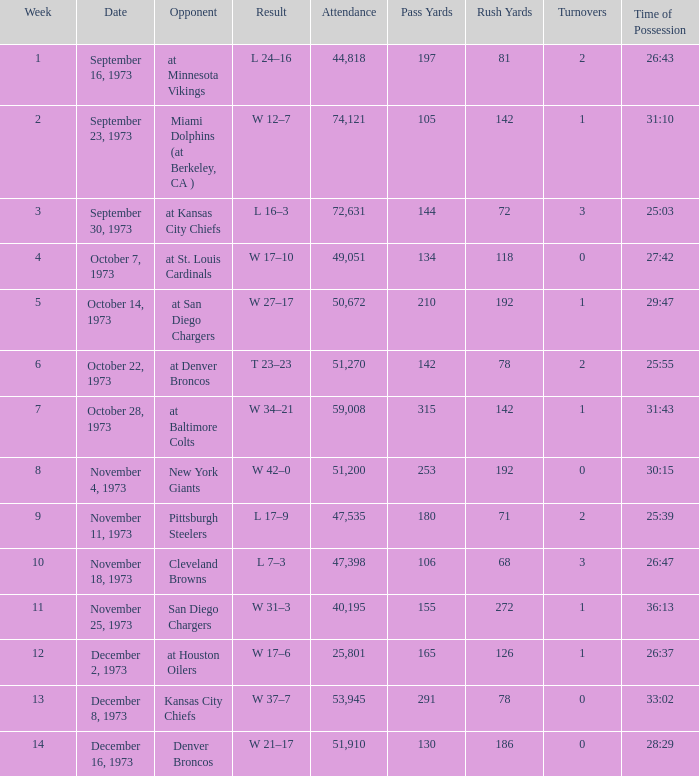What is the attendance for the game against the Kansas City Chiefs earlier than week 13? None. 